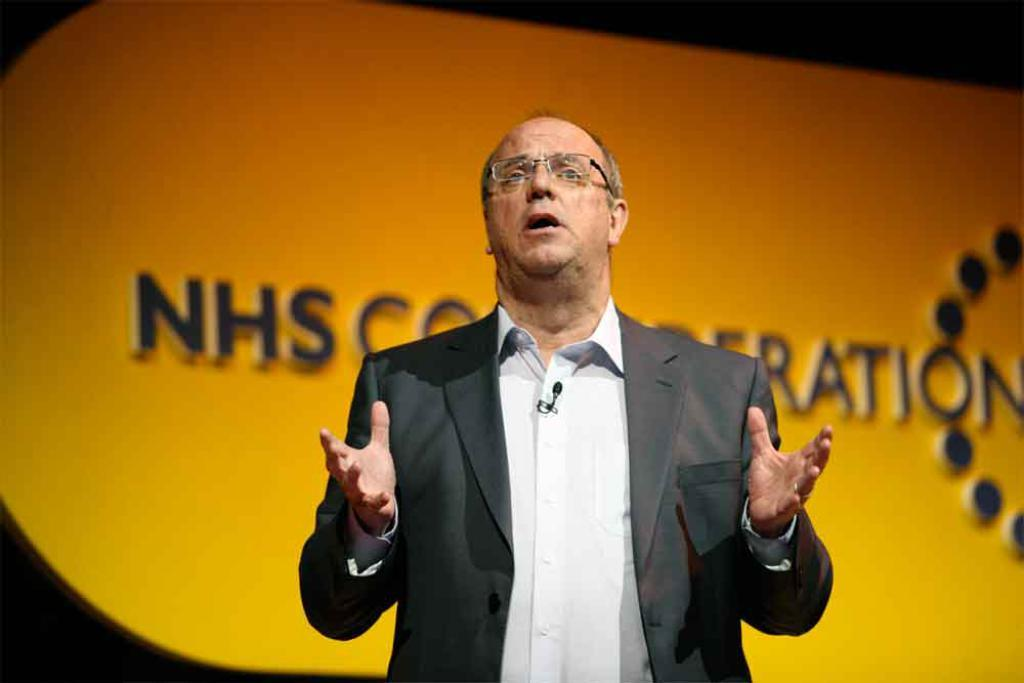What is the main subject of the image? There is a person in the image. What is the person wearing on their upper body? The person is wearing a white shirt and a black blazer. What is the person's posture in the image? The person is standing. Can you describe the background of the image? The background of the image is orange and black in color. How many geese are visible in the image? There are no geese present in the image. What type of wire system is being used by the person in the image? There is no wire system visible in the image. 